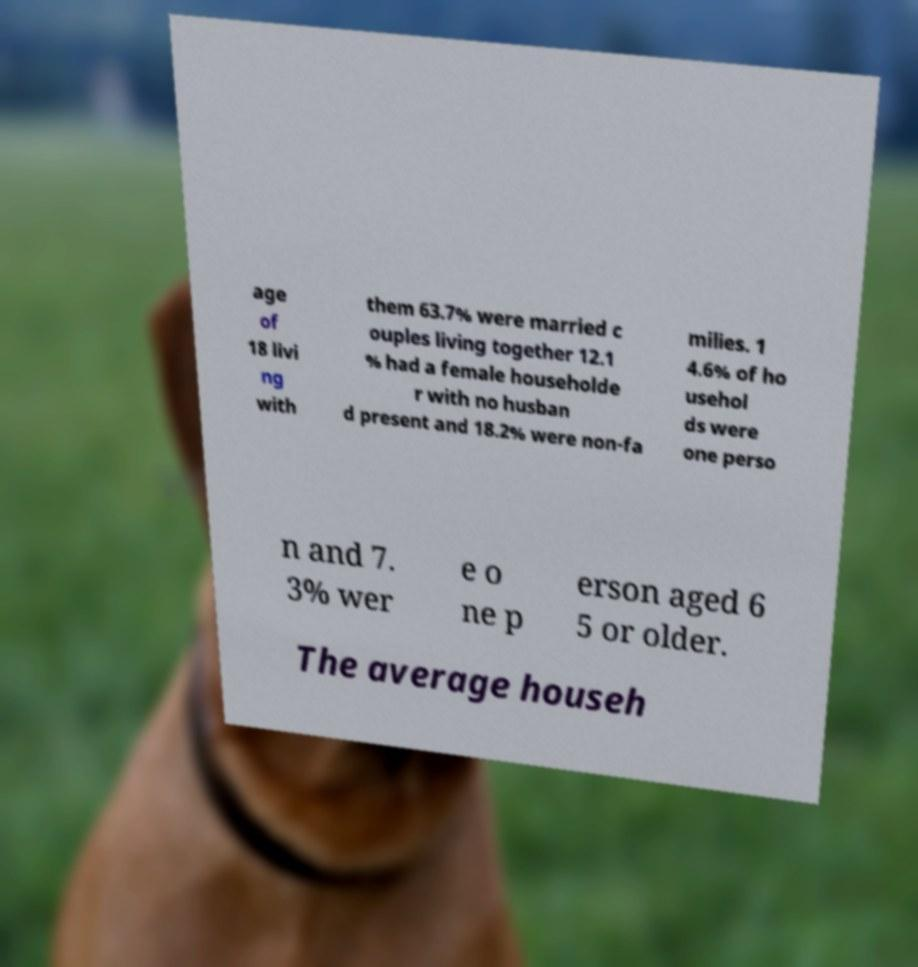Can you read and provide the text displayed in the image?This photo seems to have some interesting text. Can you extract and type it out for me? age of 18 livi ng with them 63.7% were married c ouples living together 12.1 % had a female householde r with no husban d present and 18.2% were non-fa milies. 1 4.6% of ho usehol ds were one perso n and 7. 3% wer e o ne p erson aged 6 5 or older. The average househ 